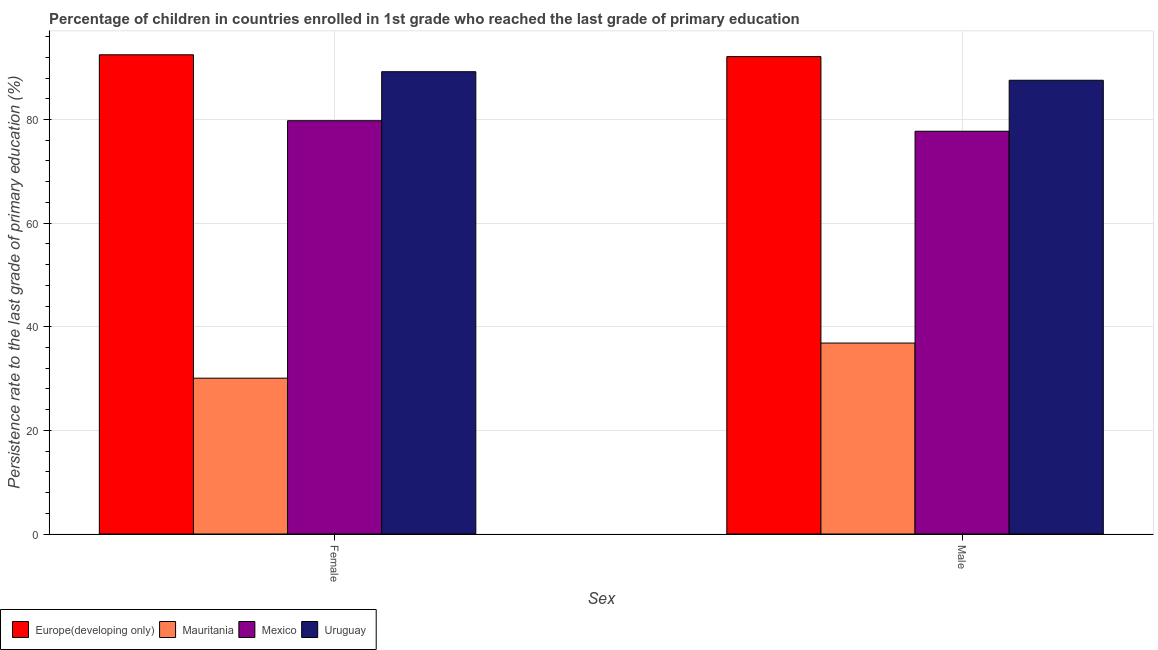How many different coloured bars are there?
Your answer should be very brief. 4. Are the number of bars on each tick of the X-axis equal?
Make the answer very short. Yes. How many bars are there on the 2nd tick from the right?
Provide a short and direct response. 4. What is the persistence rate of male students in Mexico?
Your response must be concise. 77.74. Across all countries, what is the maximum persistence rate of male students?
Give a very brief answer. 92.14. Across all countries, what is the minimum persistence rate of female students?
Provide a short and direct response. 30.07. In which country was the persistence rate of male students maximum?
Provide a succinct answer. Europe(developing only). In which country was the persistence rate of female students minimum?
Your answer should be compact. Mauritania. What is the total persistence rate of male students in the graph?
Give a very brief answer. 294.31. What is the difference between the persistence rate of male students in Mauritania and that in Mexico?
Provide a succinct answer. -40.88. What is the difference between the persistence rate of female students in Mexico and the persistence rate of male students in Mauritania?
Ensure brevity in your answer.  42.92. What is the average persistence rate of female students per country?
Your answer should be very brief. 72.89. What is the difference between the persistence rate of female students and persistence rate of male students in Uruguay?
Your response must be concise. 1.65. In how many countries, is the persistence rate of female students greater than 28 %?
Keep it short and to the point. 4. What is the ratio of the persistence rate of female students in Mauritania to that in Mexico?
Make the answer very short. 0.38. Is the persistence rate of female students in Uruguay less than that in Europe(developing only)?
Your response must be concise. Yes. What does the 2nd bar from the left in Male represents?
Your response must be concise. Mauritania. What does the 3rd bar from the right in Female represents?
Provide a short and direct response. Mauritania. Are all the bars in the graph horizontal?
Your response must be concise. No. Does the graph contain grids?
Keep it short and to the point. Yes. Where does the legend appear in the graph?
Your answer should be compact. Bottom left. How are the legend labels stacked?
Your answer should be compact. Horizontal. What is the title of the graph?
Ensure brevity in your answer.  Percentage of children in countries enrolled in 1st grade who reached the last grade of primary education. What is the label or title of the X-axis?
Keep it short and to the point. Sex. What is the label or title of the Y-axis?
Provide a succinct answer. Persistence rate to the last grade of primary education (%). What is the Persistence rate to the last grade of primary education (%) of Europe(developing only) in Female?
Offer a terse response. 92.49. What is the Persistence rate to the last grade of primary education (%) of Mauritania in Female?
Your response must be concise. 30.07. What is the Persistence rate to the last grade of primary education (%) of Mexico in Female?
Keep it short and to the point. 79.77. What is the Persistence rate to the last grade of primary education (%) of Uruguay in Female?
Offer a terse response. 89.23. What is the Persistence rate to the last grade of primary education (%) in Europe(developing only) in Male?
Provide a short and direct response. 92.14. What is the Persistence rate to the last grade of primary education (%) in Mauritania in Male?
Your response must be concise. 36.85. What is the Persistence rate to the last grade of primary education (%) in Mexico in Male?
Your response must be concise. 77.74. What is the Persistence rate to the last grade of primary education (%) of Uruguay in Male?
Provide a succinct answer. 87.58. Across all Sex, what is the maximum Persistence rate to the last grade of primary education (%) of Europe(developing only)?
Ensure brevity in your answer.  92.49. Across all Sex, what is the maximum Persistence rate to the last grade of primary education (%) of Mauritania?
Make the answer very short. 36.85. Across all Sex, what is the maximum Persistence rate to the last grade of primary education (%) of Mexico?
Keep it short and to the point. 79.77. Across all Sex, what is the maximum Persistence rate to the last grade of primary education (%) of Uruguay?
Provide a succinct answer. 89.23. Across all Sex, what is the minimum Persistence rate to the last grade of primary education (%) in Europe(developing only)?
Provide a short and direct response. 92.14. Across all Sex, what is the minimum Persistence rate to the last grade of primary education (%) of Mauritania?
Provide a short and direct response. 30.07. Across all Sex, what is the minimum Persistence rate to the last grade of primary education (%) of Mexico?
Provide a short and direct response. 77.74. Across all Sex, what is the minimum Persistence rate to the last grade of primary education (%) of Uruguay?
Keep it short and to the point. 87.58. What is the total Persistence rate to the last grade of primary education (%) in Europe(developing only) in the graph?
Keep it short and to the point. 184.63. What is the total Persistence rate to the last grade of primary education (%) in Mauritania in the graph?
Keep it short and to the point. 66.93. What is the total Persistence rate to the last grade of primary education (%) of Mexico in the graph?
Make the answer very short. 157.51. What is the total Persistence rate to the last grade of primary education (%) of Uruguay in the graph?
Ensure brevity in your answer.  176.8. What is the difference between the Persistence rate to the last grade of primary education (%) of Europe(developing only) in Female and that in Male?
Your response must be concise. 0.35. What is the difference between the Persistence rate to the last grade of primary education (%) of Mauritania in Female and that in Male?
Ensure brevity in your answer.  -6.78. What is the difference between the Persistence rate to the last grade of primary education (%) of Mexico in Female and that in Male?
Make the answer very short. 2.03. What is the difference between the Persistence rate to the last grade of primary education (%) of Uruguay in Female and that in Male?
Your answer should be compact. 1.65. What is the difference between the Persistence rate to the last grade of primary education (%) in Europe(developing only) in Female and the Persistence rate to the last grade of primary education (%) in Mauritania in Male?
Keep it short and to the point. 55.64. What is the difference between the Persistence rate to the last grade of primary education (%) in Europe(developing only) in Female and the Persistence rate to the last grade of primary education (%) in Mexico in Male?
Offer a very short reply. 14.76. What is the difference between the Persistence rate to the last grade of primary education (%) of Europe(developing only) in Female and the Persistence rate to the last grade of primary education (%) of Uruguay in Male?
Give a very brief answer. 4.92. What is the difference between the Persistence rate to the last grade of primary education (%) of Mauritania in Female and the Persistence rate to the last grade of primary education (%) of Mexico in Male?
Provide a succinct answer. -47.66. What is the difference between the Persistence rate to the last grade of primary education (%) of Mauritania in Female and the Persistence rate to the last grade of primary education (%) of Uruguay in Male?
Your answer should be very brief. -57.5. What is the difference between the Persistence rate to the last grade of primary education (%) of Mexico in Female and the Persistence rate to the last grade of primary education (%) of Uruguay in Male?
Give a very brief answer. -7.81. What is the average Persistence rate to the last grade of primary education (%) in Europe(developing only) per Sex?
Offer a terse response. 92.32. What is the average Persistence rate to the last grade of primary education (%) of Mauritania per Sex?
Your answer should be compact. 33.46. What is the average Persistence rate to the last grade of primary education (%) in Mexico per Sex?
Provide a short and direct response. 78.75. What is the average Persistence rate to the last grade of primary education (%) in Uruguay per Sex?
Keep it short and to the point. 88.4. What is the difference between the Persistence rate to the last grade of primary education (%) of Europe(developing only) and Persistence rate to the last grade of primary education (%) of Mauritania in Female?
Your response must be concise. 62.42. What is the difference between the Persistence rate to the last grade of primary education (%) in Europe(developing only) and Persistence rate to the last grade of primary education (%) in Mexico in Female?
Offer a very short reply. 12.72. What is the difference between the Persistence rate to the last grade of primary education (%) in Europe(developing only) and Persistence rate to the last grade of primary education (%) in Uruguay in Female?
Give a very brief answer. 3.27. What is the difference between the Persistence rate to the last grade of primary education (%) in Mauritania and Persistence rate to the last grade of primary education (%) in Mexico in Female?
Keep it short and to the point. -49.7. What is the difference between the Persistence rate to the last grade of primary education (%) in Mauritania and Persistence rate to the last grade of primary education (%) in Uruguay in Female?
Your response must be concise. -59.15. What is the difference between the Persistence rate to the last grade of primary education (%) of Mexico and Persistence rate to the last grade of primary education (%) of Uruguay in Female?
Your answer should be compact. -9.46. What is the difference between the Persistence rate to the last grade of primary education (%) in Europe(developing only) and Persistence rate to the last grade of primary education (%) in Mauritania in Male?
Ensure brevity in your answer.  55.29. What is the difference between the Persistence rate to the last grade of primary education (%) in Europe(developing only) and Persistence rate to the last grade of primary education (%) in Mexico in Male?
Offer a terse response. 14.4. What is the difference between the Persistence rate to the last grade of primary education (%) of Europe(developing only) and Persistence rate to the last grade of primary education (%) of Uruguay in Male?
Make the answer very short. 4.56. What is the difference between the Persistence rate to the last grade of primary education (%) of Mauritania and Persistence rate to the last grade of primary education (%) of Mexico in Male?
Make the answer very short. -40.88. What is the difference between the Persistence rate to the last grade of primary education (%) in Mauritania and Persistence rate to the last grade of primary education (%) in Uruguay in Male?
Keep it short and to the point. -50.72. What is the difference between the Persistence rate to the last grade of primary education (%) of Mexico and Persistence rate to the last grade of primary education (%) of Uruguay in Male?
Keep it short and to the point. -9.84. What is the ratio of the Persistence rate to the last grade of primary education (%) in Mauritania in Female to that in Male?
Give a very brief answer. 0.82. What is the ratio of the Persistence rate to the last grade of primary education (%) of Mexico in Female to that in Male?
Provide a succinct answer. 1.03. What is the ratio of the Persistence rate to the last grade of primary education (%) of Uruguay in Female to that in Male?
Your response must be concise. 1.02. What is the difference between the highest and the second highest Persistence rate to the last grade of primary education (%) of Europe(developing only)?
Keep it short and to the point. 0.35. What is the difference between the highest and the second highest Persistence rate to the last grade of primary education (%) in Mauritania?
Give a very brief answer. 6.78. What is the difference between the highest and the second highest Persistence rate to the last grade of primary education (%) in Mexico?
Offer a terse response. 2.03. What is the difference between the highest and the second highest Persistence rate to the last grade of primary education (%) of Uruguay?
Your answer should be very brief. 1.65. What is the difference between the highest and the lowest Persistence rate to the last grade of primary education (%) in Europe(developing only)?
Provide a short and direct response. 0.35. What is the difference between the highest and the lowest Persistence rate to the last grade of primary education (%) of Mauritania?
Provide a short and direct response. 6.78. What is the difference between the highest and the lowest Persistence rate to the last grade of primary education (%) of Mexico?
Your response must be concise. 2.03. What is the difference between the highest and the lowest Persistence rate to the last grade of primary education (%) in Uruguay?
Your answer should be very brief. 1.65. 